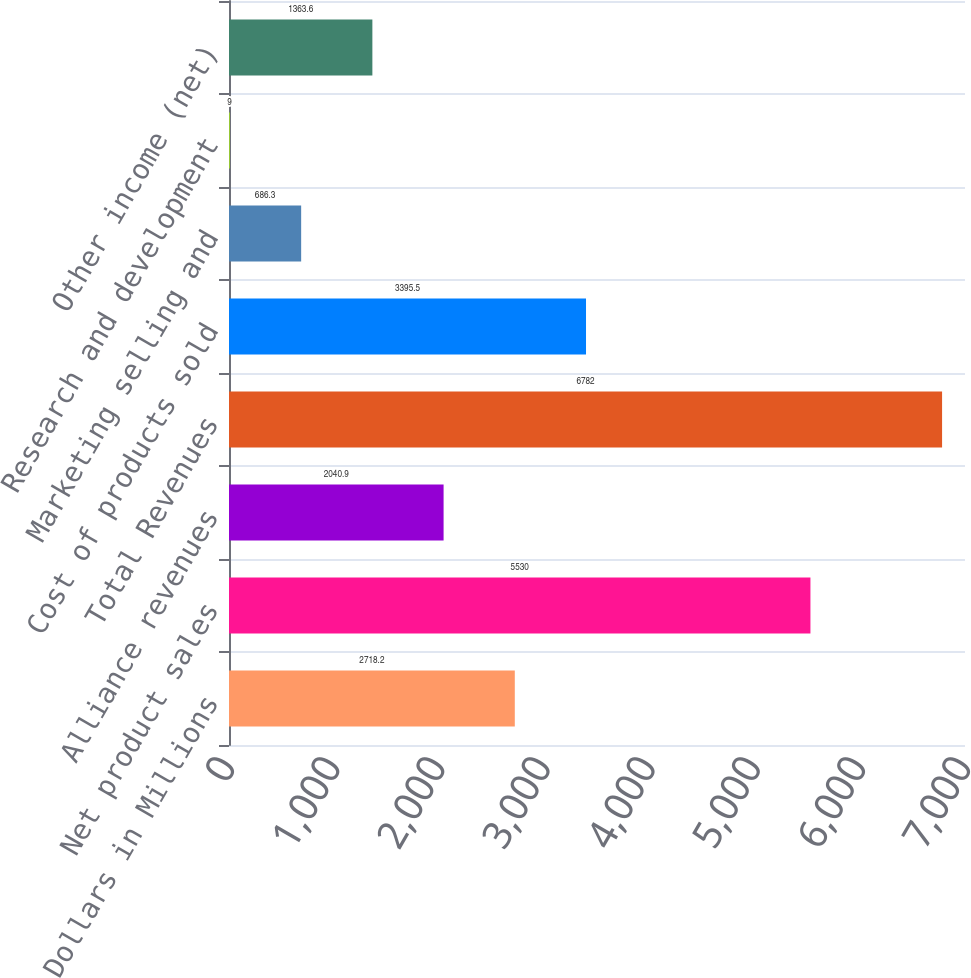Convert chart. <chart><loc_0><loc_0><loc_500><loc_500><bar_chart><fcel>Dollars in Millions<fcel>Net product sales<fcel>Alliance revenues<fcel>Total Revenues<fcel>Cost of products sold<fcel>Marketing selling and<fcel>Research and development<fcel>Other income (net)<nl><fcel>2718.2<fcel>5530<fcel>2040.9<fcel>6782<fcel>3395.5<fcel>686.3<fcel>9<fcel>1363.6<nl></chart> 